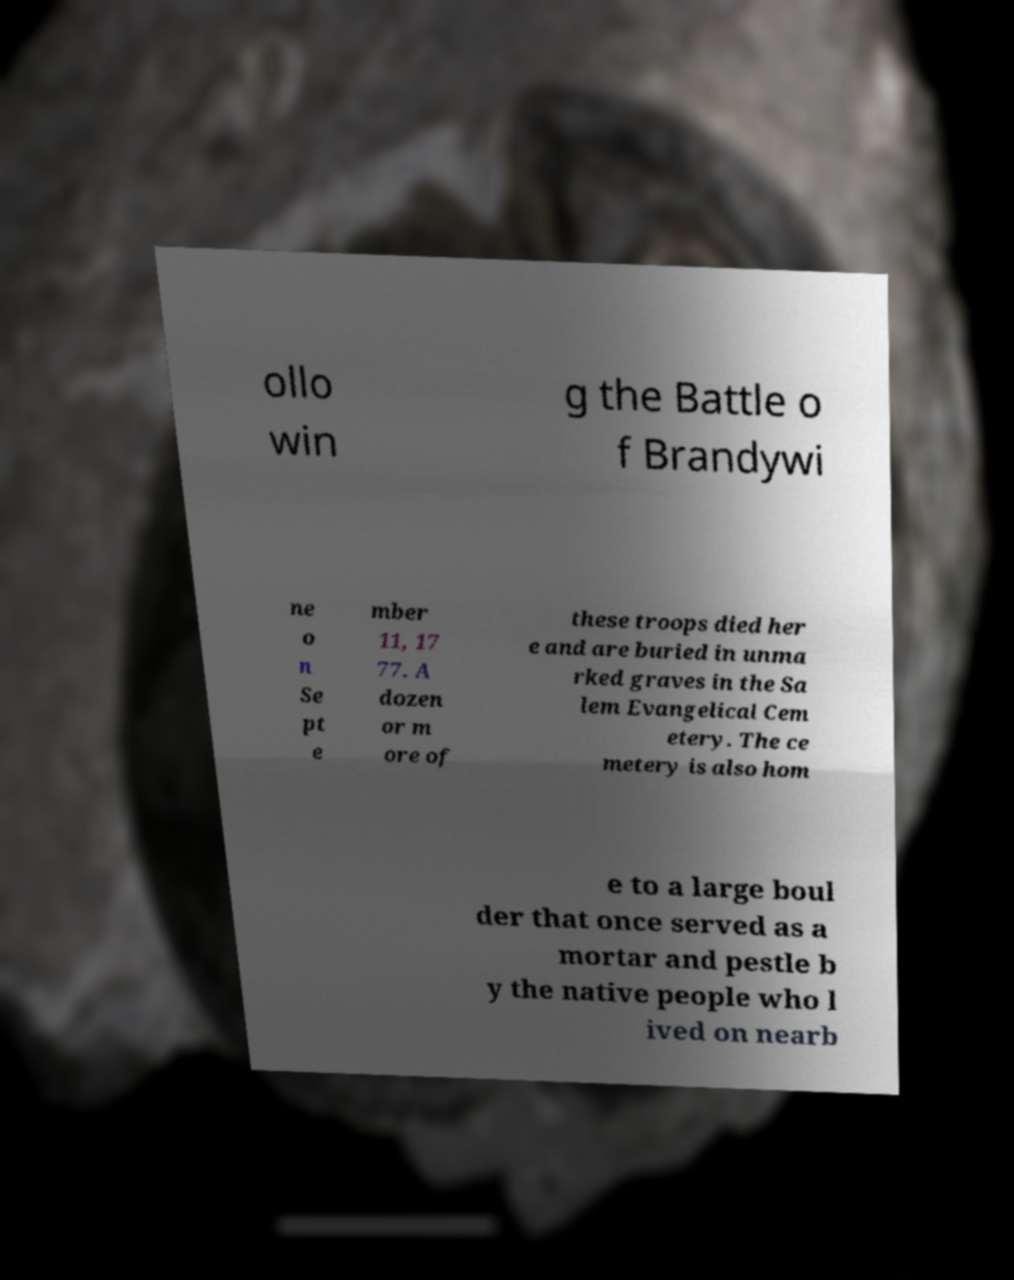Please identify and transcribe the text found in this image. ollo win g the Battle o f Brandywi ne o n Se pt e mber 11, 17 77. A dozen or m ore of these troops died her e and are buried in unma rked graves in the Sa lem Evangelical Cem etery. The ce metery is also hom e to a large boul der that once served as a mortar and pestle b y the native people who l ived on nearb 